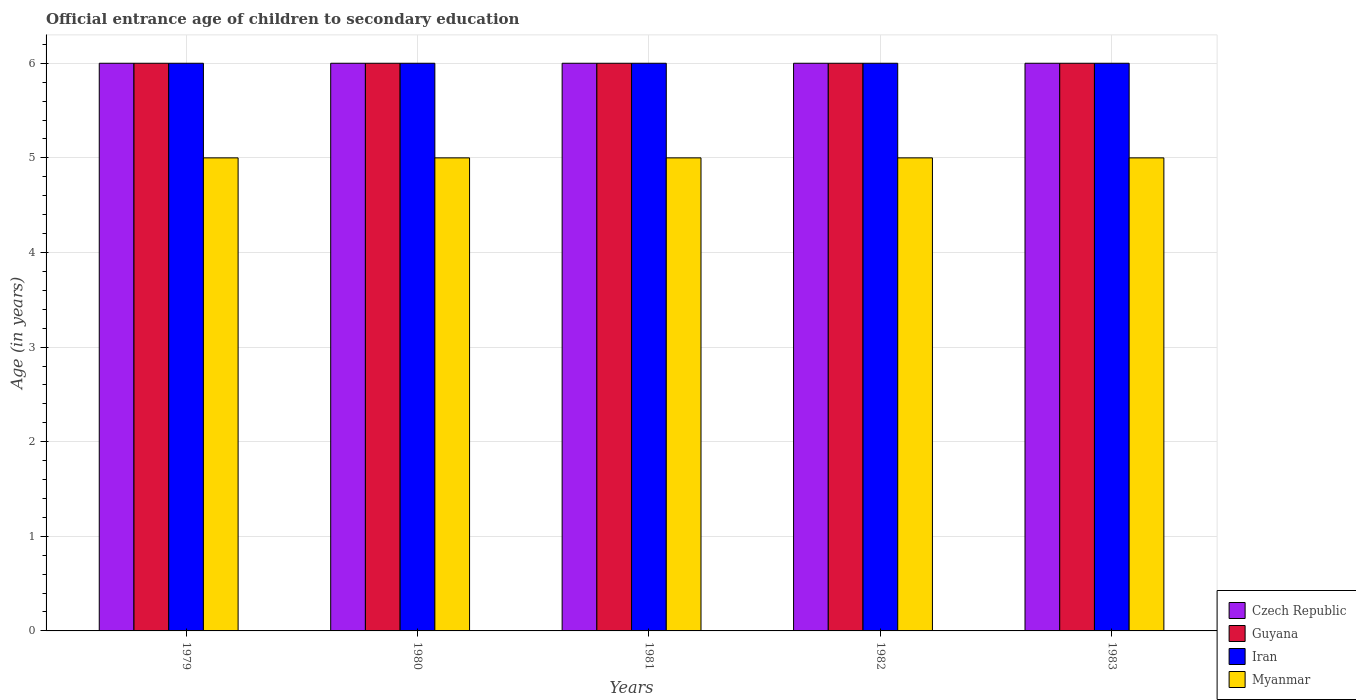How many different coloured bars are there?
Your response must be concise. 4. How many groups of bars are there?
Provide a succinct answer. 5. Are the number of bars on each tick of the X-axis equal?
Offer a terse response. Yes. How many bars are there on the 4th tick from the left?
Your answer should be compact. 4. How many bars are there on the 1st tick from the right?
Provide a succinct answer. 4. What is the label of the 3rd group of bars from the left?
Offer a very short reply. 1981. In how many cases, is the number of bars for a given year not equal to the number of legend labels?
Provide a short and direct response. 0. What is the secondary school starting age of children in Guyana in 1983?
Provide a succinct answer. 6. Across all years, what is the maximum secondary school starting age of children in Myanmar?
Provide a short and direct response. 5. Across all years, what is the minimum secondary school starting age of children in Czech Republic?
Your answer should be very brief. 6. In which year was the secondary school starting age of children in Myanmar maximum?
Keep it short and to the point. 1979. In which year was the secondary school starting age of children in Iran minimum?
Your answer should be very brief. 1979. What is the total secondary school starting age of children in Czech Republic in the graph?
Your answer should be compact. 30. What is the difference between the secondary school starting age of children in Guyana in 1981 and the secondary school starting age of children in Myanmar in 1980?
Provide a short and direct response. 1. In the year 1979, what is the difference between the secondary school starting age of children in Iran and secondary school starting age of children in Myanmar?
Ensure brevity in your answer.  1. Is the secondary school starting age of children in Iran in 1982 less than that in 1983?
Your response must be concise. No. Is the difference between the secondary school starting age of children in Iran in 1980 and 1981 greater than the difference between the secondary school starting age of children in Myanmar in 1980 and 1981?
Your answer should be compact. No. What is the difference between the highest and the second highest secondary school starting age of children in Czech Republic?
Ensure brevity in your answer.  0. What is the difference between the highest and the lowest secondary school starting age of children in Myanmar?
Provide a succinct answer. 0. In how many years, is the secondary school starting age of children in Myanmar greater than the average secondary school starting age of children in Myanmar taken over all years?
Provide a short and direct response. 0. What does the 4th bar from the left in 1979 represents?
Keep it short and to the point. Myanmar. What does the 3rd bar from the right in 1981 represents?
Ensure brevity in your answer.  Guyana. Is it the case that in every year, the sum of the secondary school starting age of children in Guyana and secondary school starting age of children in Iran is greater than the secondary school starting age of children in Myanmar?
Your response must be concise. Yes. How many bars are there?
Offer a terse response. 20. Are all the bars in the graph horizontal?
Keep it short and to the point. No. Are the values on the major ticks of Y-axis written in scientific E-notation?
Make the answer very short. No. Does the graph contain any zero values?
Offer a very short reply. No. Where does the legend appear in the graph?
Your answer should be compact. Bottom right. How many legend labels are there?
Keep it short and to the point. 4. How are the legend labels stacked?
Your response must be concise. Vertical. What is the title of the graph?
Keep it short and to the point. Official entrance age of children to secondary education. Does "Gabon" appear as one of the legend labels in the graph?
Your answer should be compact. No. What is the label or title of the Y-axis?
Offer a very short reply. Age (in years). What is the Age (in years) in Iran in 1979?
Make the answer very short. 6. What is the Age (in years) of Guyana in 1981?
Keep it short and to the point. 6. What is the Age (in years) of Iran in 1981?
Offer a terse response. 6. What is the Age (in years) of Myanmar in 1981?
Ensure brevity in your answer.  5. What is the Age (in years) in Czech Republic in 1982?
Provide a succinct answer. 6. What is the Age (in years) of Czech Republic in 1983?
Your answer should be very brief. 6. Across all years, what is the maximum Age (in years) in Czech Republic?
Provide a succinct answer. 6. Across all years, what is the maximum Age (in years) of Guyana?
Give a very brief answer. 6. Across all years, what is the maximum Age (in years) in Iran?
Offer a very short reply. 6. Across all years, what is the minimum Age (in years) in Iran?
Give a very brief answer. 6. Across all years, what is the minimum Age (in years) in Myanmar?
Make the answer very short. 5. What is the total Age (in years) in Iran in the graph?
Give a very brief answer. 30. What is the difference between the Age (in years) in Czech Republic in 1979 and that in 1980?
Offer a terse response. 0. What is the difference between the Age (in years) of Czech Republic in 1979 and that in 1981?
Your response must be concise. 0. What is the difference between the Age (in years) of Iran in 1979 and that in 1981?
Offer a very short reply. 0. What is the difference between the Age (in years) of Czech Republic in 1979 and that in 1982?
Your response must be concise. 0. What is the difference between the Age (in years) in Guyana in 1979 and that in 1982?
Your answer should be very brief. 0. What is the difference between the Age (in years) of Czech Republic in 1979 and that in 1983?
Provide a succinct answer. 0. What is the difference between the Age (in years) in Czech Republic in 1980 and that in 1981?
Provide a succinct answer. 0. What is the difference between the Age (in years) of Myanmar in 1980 and that in 1981?
Your response must be concise. 0. What is the difference between the Age (in years) of Czech Republic in 1980 and that in 1982?
Provide a short and direct response. 0. What is the difference between the Age (in years) in Guyana in 1980 and that in 1982?
Offer a very short reply. 0. What is the difference between the Age (in years) in Czech Republic in 1980 and that in 1983?
Your answer should be very brief. 0. What is the difference between the Age (in years) of Iran in 1980 and that in 1983?
Make the answer very short. 0. What is the difference between the Age (in years) of Myanmar in 1980 and that in 1983?
Your answer should be compact. 0. What is the difference between the Age (in years) in Guyana in 1981 and that in 1983?
Your response must be concise. 0. What is the difference between the Age (in years) of Czech Republic in 1982 and that in 1983?
Ensure brevity in your answer.  0. What is the difference between the Age (in years) of Guyana in 1982 and that in 1983?
Provide a short and direct response. 0. What is the difference between the Age (in years) of Myanmar in 1982 and that in 1983?
Provide a succinct answer. 0. What is the difference between the Age (in years) in Czech Republic in 1979 and the Age (in years) in Guyana in 1981?
Provide a short and direct response. 0. What is the difference between the Age (in years) in Czech Republic in 1979 and the Age (in years) in Iran in 1981?
Offer a terse response. 0. What is the difference between the Age (in years) of Czech Republic in 1979 and the Age (in years) of Myanmar in 1981?
Your answer should be very brief. 1. What is the difference between the Age (in years) in Guyana in 1979 and the Age (in years) in Iran in 1981?
Make the answer very short. 0. What is the difference between the Age (in years) of Czech Republic in 1979 and the Age (in years) of Iran in 1982?
Offer a very short reply. 0. What is the difference between the Age (in years) in Czech Republic in 1979 and the Age (in years) in Myanmar in 1982?
Your response must be concise. 1. What is the difference between the Age (in years) in Guyana in 1979 and the Age (in years) in Myanmar in 1982?
Keep it short and to the point. 1. What is the difference between the Age (in years) of Iran in 1979 and the Age (in years) of Myanmar in 1982?
Offer a very short reply. 1. What is the difference between the Age (in years) in Czech Republic in 1979 and the Age (in years) in Guyana in 1983?
Provide a succinct answer. 0. What is the difference between the Age (in years) of Czech Republic in 1979 and the Age (in years) of Iran in 1983?
Give a very brief answer. 0. What is the difference between the Age (in years) in Czech Republic in 1979 and the Age (in years) in Myanmar in 1983?
Your answer should be very brief. 1. What is the difference between the Age (in years) in Guyana in 1979 and the Age (in years) in Myanmar in 1983?
Provide a succinct answer. 1. What is the difference between the Age (in years) of Iran in 1979 and the Age (in years) of Myanmar in 1983?
Give a very brief answer. 1. What is the difference between the Age (in years) in Czech Republic in 1980 and the Age (in years) in Myanmar in 1981?
Give a very brief answer. 1. What is the difference between the Age (in years) in Guyana in 1980 and the Age (in years) in Iran in 1981?
Keep it short and to the point. 0. What is the difference between the Age (in years) of Czech Republic in 1980 and the Age (in years) of Iran in 1982?
Give a very brief answer. 0. What is the difference between the Age (in years) in Guyana in 1980 and the Age (in years) in Myanmar in 1982?
Provide a short and direct response. 1. What is the difference between the Age (in years) of Iran in 1980 and the Age (in years) of Myanmar in 1982?
Give a very brief answer. 1. What is the difference between the Age (in years) in Czech Republic in 1980 and the Age (in years) in Iran in 1983?
Provide a short and direct response. 0. What is the difference between the Age (in years) in Guyana in 1980 and the Age (in years) in Iran in 1983?
Give a very brief answer. 0. What is the difference between the Age (in years) in Iran in 1980 and the Age (in years) in Myanmar in 1983?
Offer a very short reply. 1. What is the difference between the Age (in years) in Czech Republic in 1981 and the Age (in years) in Myanmar in 1982?
Offer a very short reply. 1. What is the difference between the Age (in years) of Guyana in 1981 and the Age (in years) of Myanmar in 1982?
Offer a terse response. 1. What is the difference between the Age (in years) in Czech Republic in 1981 and the Age (in years) in Guyana in 1983?
Your answer should be compact. 0. What is the difference between the Age (in years) of Czech Republic in 1981 and the Age (in years) of Myanmar in 1983?
Offer a very short reply. 1. What is the difference between the Age (in years) in Guyana in 1981 and the Age (in years) in Iran in 1983?
Make the answer very short. 0. What is the difference between the Age (in years) in Czech Republic in 1982 and the Age (in years) in Guyana in 1983?
Offer a very short reply. 0. What is the difference between the Age (in years) of Czech Republic in 1982 and the Age (in years) of Myanmar in 1983?
Your answer should be compact. 1. What is the difference between the Age (in years) in Guyana in 1982 and the Age (in years) in Myanmar in 1983?
Keep it short and to the point. 1. What is the average Age (in years) in Guyana per year?
Offer a very short reply. 6. What is the average Age (in years) in Iran per year?
Provide a succinct answer. 6. In the year 1979, what is the difference between the Age (in years) in Czech Republic and Age (in years) in Iran?
Offer a very short reply. 0. In the year 1979, what is the difference between the Age (in years) in Czech Republic and Age (in years) in Myanmar?
Offer a terse response. 1. In the year 1979, what is the difference between the Age (in years) of Guyana and Age (in years) of Myanmar?
Keep it short and to the point. 1. In the year 1979, what is the difference between the Age (in years) in Iran and Age (in years) in Myanmar?
Keep it short and to the point. 1. In the year 1980, what is the difference between the Age (in years) in Czech Republic and Age (in years) in Guyana?
Make the answer very short. 0. In the year 1980, what is the difference between the Age (in years) in Czech Republic and Age (in years) in Iran?
Provide a short and direct response. 0. In the year 1980, what is the difference between the Age (in years) of Guyana and Age (in years) of Iran?
Offer a very short reply. 0. In the year 1980, what is the difference between the Age (in years) in Guyana and Age (in years) in Myanmar?
Offer a very short reply. 1. In the year 1980, what is the difference between the Age (in years) in Iran and Age (in years) in Myanmar?
Your answer should be very brief. 1. In the year 1981, what is the difference between the Age (in years) in Czech Republic and Age (in years) in Guyana?
Your answer should be very brief. 0. In the year 1981, what is the difference between the Age (in years) of Czech Republic and Age (in years) of Myanmar?
Give a very brief answer. 1. In the year 1981, what is the difference between the Age (in years) in Guyana and Age (in years) in Iran?
Offer a very short reply. 0. In the year 1981, what is the difference between the Age (in years) of Iran and Age (in years) of Myanmar?
Give a very brief answer. 1. In the year 1982, what is the difference between the Age (in years) of Guyana and Age (in years) of Iran?
Your answer should be compact. 0. In the year 1982, what is the difference between the Age (in years) in Guyana and Age (in years) in Myanmar?
Make the answer very short. 1. In the year 1983, what is the difference between the Age (in years) in Czech Republic and Age (in years) in Guyana?
Offer a very short reply. 0. In the year 1983, what is the difference between the Age (in years) in Czech Republic and Age (in years) in Myanmar?
Provide a short and direct response. 1. In the year 1983, what is the difference between the Age (in years) of Guyana and Age (in years) of Iran?
Your response must be concise. 0. In the year 1983, what is the difference between the Age (in years) in Guyana and Age (in years) in Myanmar?
Your response must be concise. 1. What is the ratio of the Age (in years) in Guyana in 1979 to that in 1980?
Make the answer very short. 1. What is the ratio of the Age (in years) of Iran in 1979 to that in 1980?
Give a very brief answer. 1. What is the ratio of the Age (in years) in Czech Republic in 1979 to that in 1982?
Keep it short and to the point. 1. What is the ratio of the Age (in years) of Guyana in 1979 to that in 1982?
Your response must be concise. 1. What is the ratio of the Age (in years) in Guyana in 1979 to that in 1983?
Give a very brief answer. 1. What is the ratio of the Age (in years) in Myanmar in 1979 to that in 1983?
Offer a very short reply. 1. What is the ratio of the Age (in years) of Czech Republic in 1980 to that in 1981?
Offer a terse response. 1. What is the ratio of the Age (in years) of Iran in 1980 to that in 1981?
Your answer should be compact. 1. What is the ratio of the Age (in years) of Iran in 1980 to that in 1982?
Offer a terse response. 1. What is the ratio of the Age (in years) of Myanmar in 1980 to that in 1982?
Make the answer very short. 1. What is the ratio of the Age (in years) in Czech Republic in 1981 to that in 1982?
Provide a succinct answer. 1. What is the ratio of the Age (in years) of Iran in 1981 to that in 1982?
Provide a short and direct response. 1. What is the ratio of the Age (in years) in Myanmar in 1981 to that in 1982?
Ensure brevity in your answer.  1. What is the ratio of the Age (in years) in Czech Republic in 1981 to that in 1983?
Provide a succinct answer. 1. What is the ratio of the Age (in years) in Czech Republic in 1982 to that in 1983?
Your answer should be compact. 1. What is the ratio of the Age (in years) in Guyana in 1982 to that in 1983?
Your answer should be very brief. 1. What is the ratio of the Age (in years) of Myanmar in 1982 to that in 1983?
Offer a terse response. 1. What is the difference between the highest and the second highest Age (in years) in Czech Republic?
Provide a short and direct response. 0. What is the difference between the highest and the second highest Age (in years) in Iran?
Provide a short and direct response. 0. What is the difference between the highest and the lowest Age (in years) in Czech Republic?
Offer a terse response. 0. What is the difference between the highest and the lowest Age (in years) in Guyana?
Give a very brief answer. 0. 